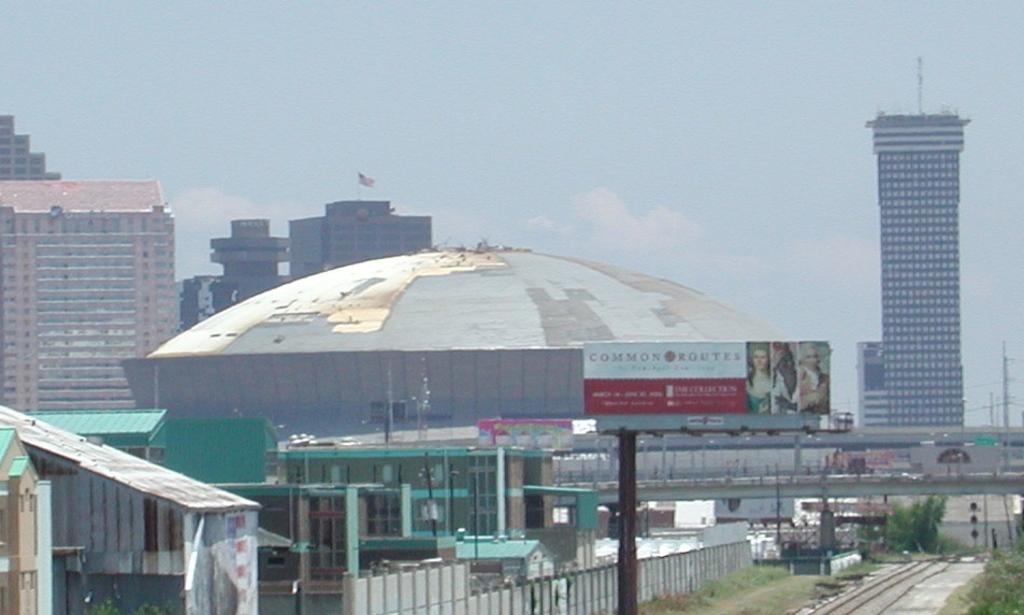Could you give a brief overview of what you see in this image? This image consists of buildings. At the bottom, we can see the tracks. Beside which, there is green grass on the ground along with a fencing. In the front, we can see a bridge. At the top, there is sky. On the right, we can see a skyscraper. 